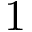<formula> <loc_0><loc_0><loc_500><loc_500>1</formula> 